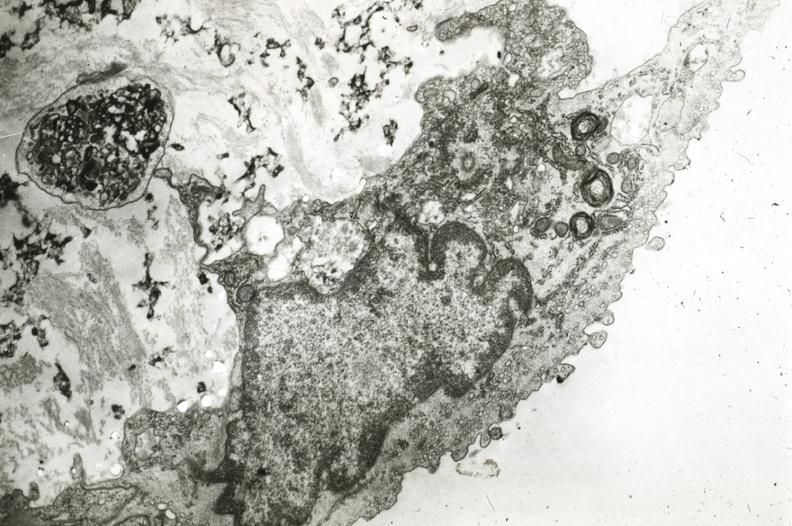what is present?
Answer the question using a single word or phrase. Vasculature 